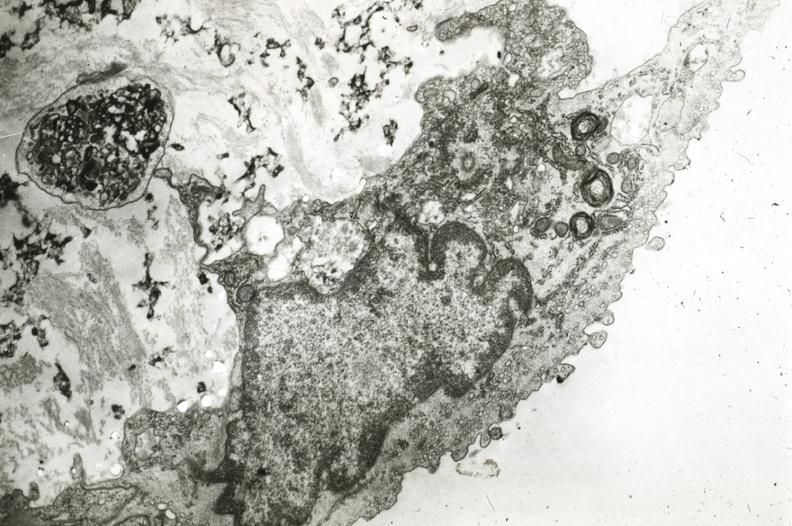what is present?
Answer the question using a single word or phrase. Vasculature 